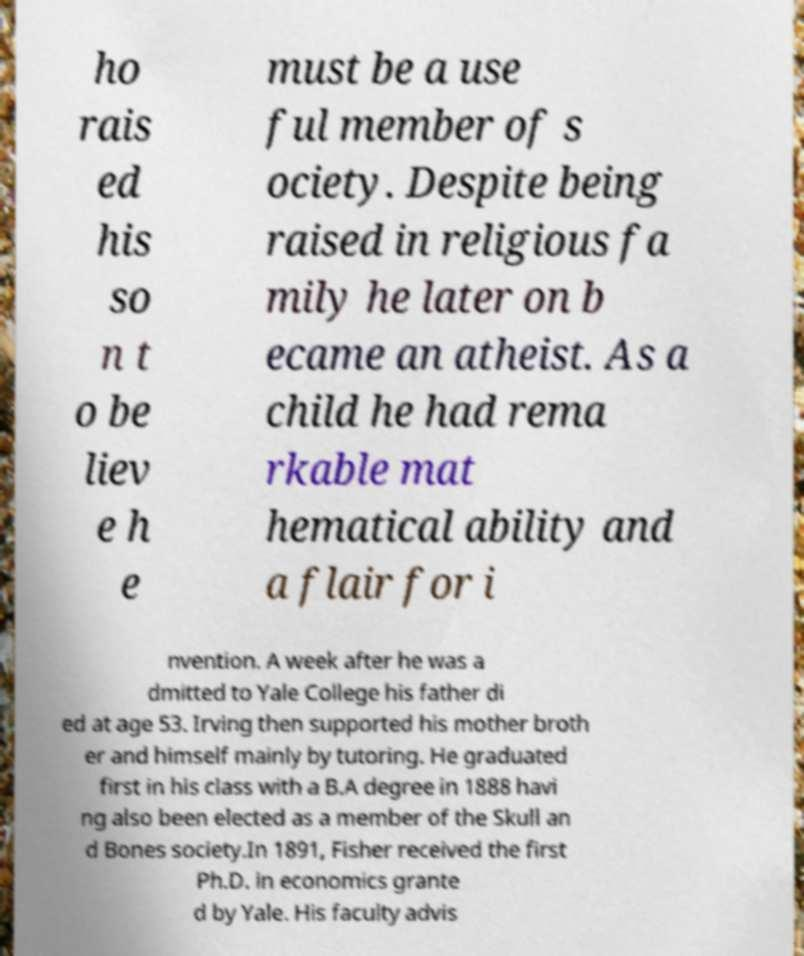Could you assist in decoding the text presented in this image and type it out clearly? ho rais ed his so n t o be liev e h e must be a use ful member of s ociety. Despite being raised in religious fa mily he later on b ecame an atheist. As a child he had rema rkable mat hematical ability and a flair for i nvention. A week after he was a dmitted to Yale College his father di ed at age 53. Irving then supported his mother broth er and himself mainly by tutoring. He graduated first in his class with a B.A degree in 1888 havi ng also been elected as a member of the Skull an d Bones society.In 1891, Fisher received the first Ph.D. in economics grante d by Yale. His faculty advis 